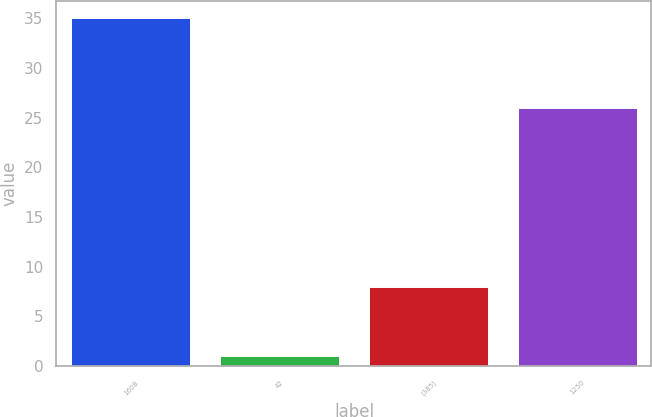Convert chart to OTSL. <chart><loc_0><loc_0><loc_500><loc_500><bar_chart><fcel>1608<fcel>42<fcel>(385)<fcel>1250<nl><fcel>35<fcel>1<fcel>8<fcel>26<nl></chart> 